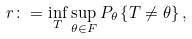Convert formula to latex. <formula><loc_0><loc_0><loc_500><loc_500>r \colon = \inf _ { T } \sup _ { \theta \in F } P _ { \theta } \left \{ T \neq \theta \right \} ,</formula> 